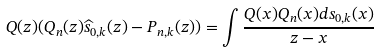<formula> <loc_0><loc_0><loc_500><loc_500>Q ( z ) ( Q _ { n } ( z ) \widehat { s } _ { 0 , k } ( z ) - P _ { { n } , k } ( z ) ) = \int \frac { Q ( x ) Q _ { n } ( x ) d s _ { 0 , k } ( x ) } { z - x }</formula> 